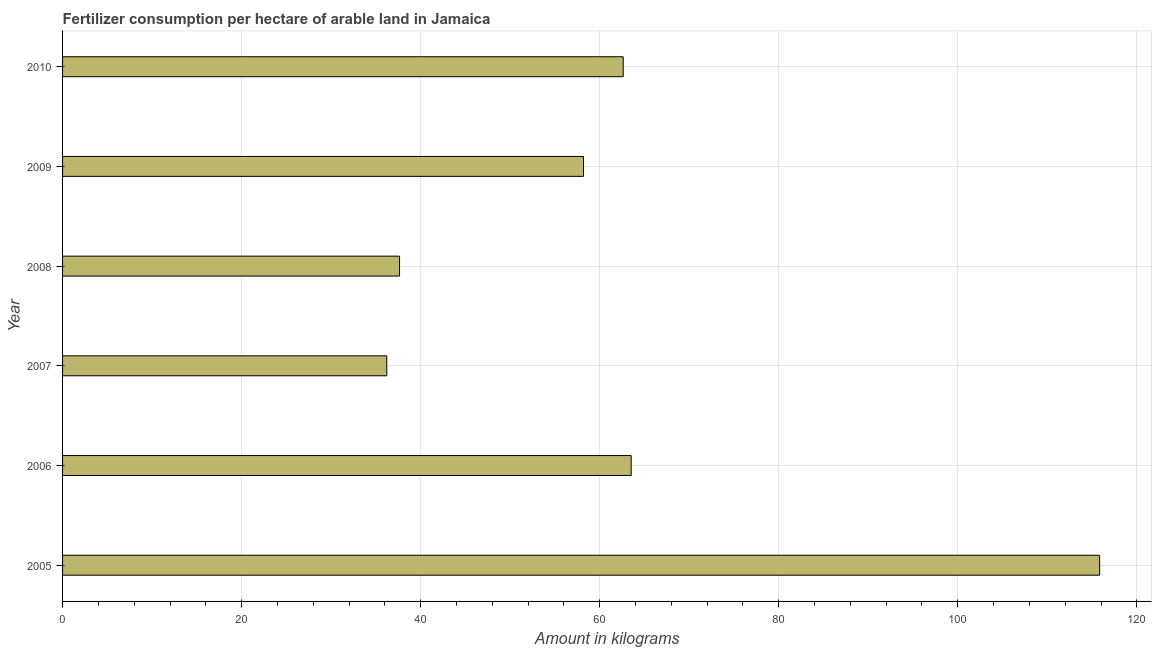Does the graph contain any zero values?
Make the answer very short. No. What is the title of the graph?
Your answer should be compact. Fertilizer consumption per hectare of arable land in Jamaica . What is the label or title of the X-axis?
Your answer should be compact. Amount in kilograms. What is the amount of fertilizer consumption in 2006?
Your answer should be compact. 63.52. Across all years, what is the maximum amount of fertilizer consumption?
Your answer should be very brief. 115.84. Across all years, what is the minimum amount of fertilizer consumption?
Ensure brevity in your answer.  36.22. In which year was the amount of fertilizer consumption maximum?
Ensure brevity in your answer.  2005. What is the sum of the amount of fertilizer consumption?
Give a very brief answer. 374.03. What is the difference between the amount of fertilizer consumption in 2007 and 2010?
Give a very brief answer. -26.41. What is the average amount of fertilizer consumption per year?
Make the answer very short. 62.34. What is the median amount of fertilizer consumption?
Ensure brevity in your answer.  60.41. In how many years, is the amount of fertilizer consumption greater than 56 kg?
Offer a very short reply. 4. Do a majority of the years between 2008 and 2009 (inclusive) have amount of fertilizer consumption greater than 40 kg?
Offer a terse response. No. What is the ratio of the amount of fertilizer consumption in 2006 to that in 2008?
Offer a very short reply. 1.69. Is the amount of fertilizer consumption in 2008 less than that in 2009?
Give a very brief answer. Yes. What is the difference between the highest and the second highest amount of fertilizer consumption?
Provide a succinct answer. 52.33. Is the sum of the amount of fertilizer consumption in 2006 and 2008 greater than the maximum amount of fertilizer consumption across all years?
Make the answer very short. No. What is the difference between the highest and the lowest amount of fertilizer consumption?
Keep it short and to the point. 79.63. How many bars are there?
Ensure brevity in your answer.  6. Are all the bars in the graph horizontal?
Keep it short and to the point. Yes. Are the values on the major ticks of X-axis written in scientific E-notation?
Your response must be concise. No. What is the Amount in kilograms in 2005?
Offer a terse response. 115.84. What is the Amount in kilograms of 2006?
Offer a terse response. 63.52. What is the Amount in kilograms in 2007?
Ensure brevity in your answer.  36.22. What is the Amount in kilograms of 2008?
Keep it short and to the point. 37.64. What is the Amount in kilograms in 2009?
Provide a succinct answer. 58.19. What is the Amount in kilograms in 2010?
Provide a short and direct response. 62.62. What is the difference between the Amount in kilograms in 2005 and 2006?
Provide a succinct answer. 52.33. What is the difference between the Amount in kilograms in 2005 and 2007?
Your answer should be very brief. 79.63. What is the difference between the Amount in kilograms in 2005 and 2008?
Keep it short and to the point. 78.2. What is the difference between the Amount in kilograms in 2005 and 2009?
Your answer should be very brief. 57.65. What is the difference between the Amount in kilograms in 2005 and 2010?
Ensure brevity in your answer.  53.22. What is the difference between the Amount in kilograms in 2006 and 2007?
Make the answer very short. 27.3. What is the difference between the Amount in kilograms in 2006 and 2008?
Provide a short and direct response. 25.87. What is the difference between the Amount in kilograms in 2006 and 2009?
Give a very brief answer. 5.32. What is the difference between the Amount in kilograms in 2006 and 2010?
Provide a short and direct response. 0.89. What is the difference between the Amount in kilograms in 2007 and 2008?
Make the answer very short. -1.43. What is the difference between the Amount in kilograms in 2007 and 2009?
Ensure brevity in your answer.  -21.98. What is the difference between the Amount in kilograms in 2007 and 2010?
Your answer should be compact. -26.41. What is the difference between the Amount in kilograms in 2008 and 2009?
Keep it short and to the point. -20.55. What is the difference between the Amount in kilograms in 2008 and 2010?
Keep it short and to the point. -24.98. What is the difference between the Amount in kilograms in 2009 and 2010?
Your answer should be very brief. -4.43. What is the ratio of the Amount in kilograms in 2005 to that in 2006?
Offer a very short reply. 1.82. What is the ratio of the Amount in kilograms in 2005 to that in 2007?
Make the answer very short. 3.2. What is the ratio of the Amount in kilograms in 2005 to that in 2008?
Keep it short and to the point. 3.08. What is the ratio of the Amount in kilograms in 2005 to that in 2009?
Your answer should be compact. 1.99. What is the ratio of the Amount in kilograms in 2005 to that in 2010?
Provide a short and direct response. 1.85. What is the ratio of the Amount in kilograms in 2006 to that in 2007?
Offer a terse response. 1.75. What is the ratio of the Amount in kilograms in 2006 to that in 2008?
Offer a terse response. 1.69. What is the ratio of the Amount in kilograms in 2006 to that in 2009?
Provide a succinct answer. 1.09. What is the ratio of the Amount in kilograms in 2007 to that in 2009?
Offer a very short reply. 0.62. What is the ratio of the Amount in kilograms in 2007 to that in 2010?
Keep it short and to the point. 0.58. What is the ratio of the Amount in kilograms in 2008 to that in 2009?
Your answer should be compact. 0.65. What is the ratio of the Amount in kilograms in 2008 to that in 2010?
Offer a terse response. 0.6. What is the ratio of the Amount in kilograms in 2009 to that in 2010?
Give a very brief answer. 0.93. 